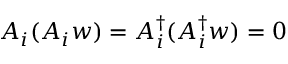<formula> <loc_0><loc_0><loc_500><loc_500>A _ { i } ( A _ { i } w ) = A _ { i } ^ { \dagger } ( A _ { i } ^ { \dagger } w ) = 0</formula> 